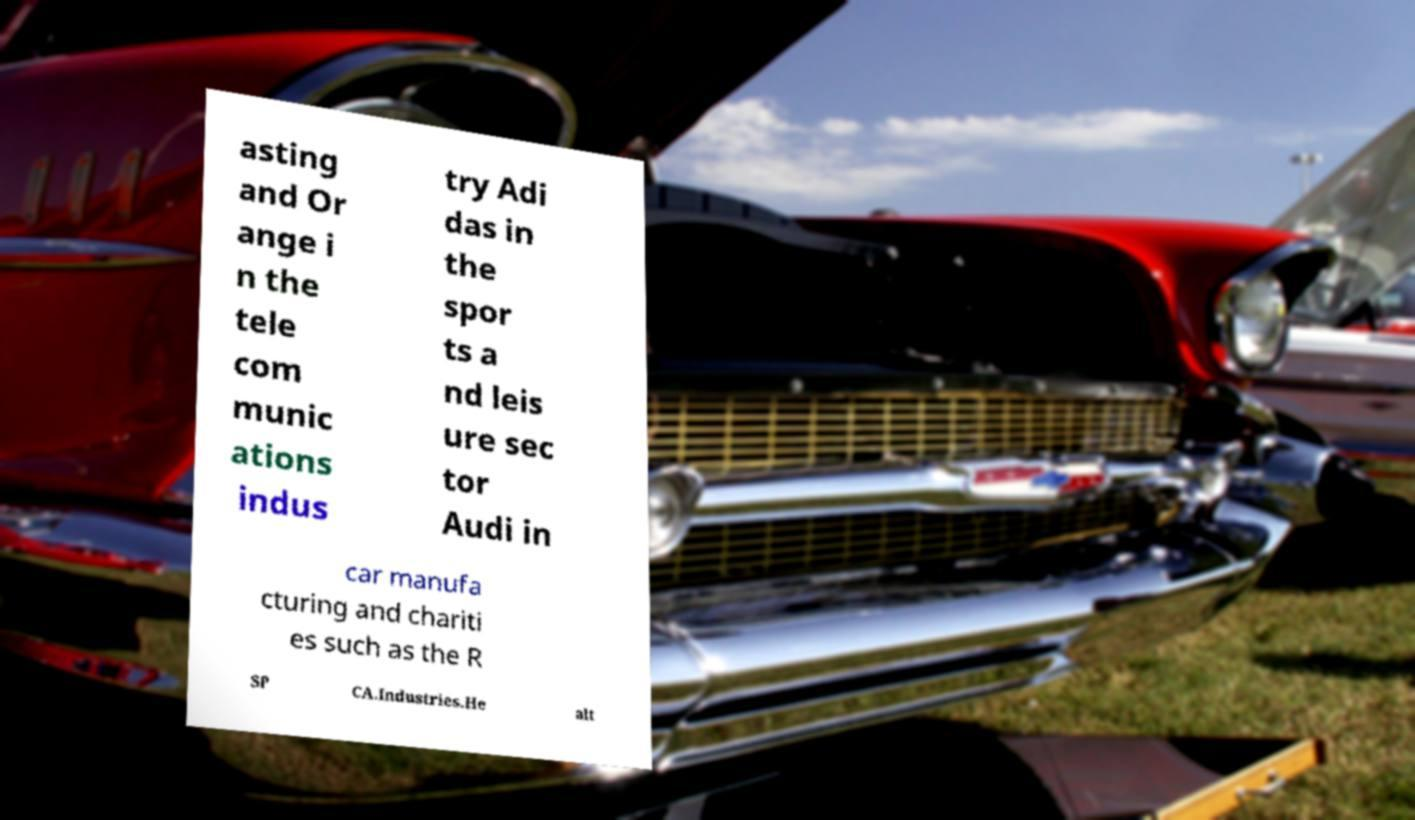Please read and relay the text visible in this image. What does it say? asting and Or ange i n the tele com munic ations indus try Adi das in the spor ts a nd leis ure sec tor Audi in car manufa cturing and chariti es such as the R SP CA.Industries.He alt 